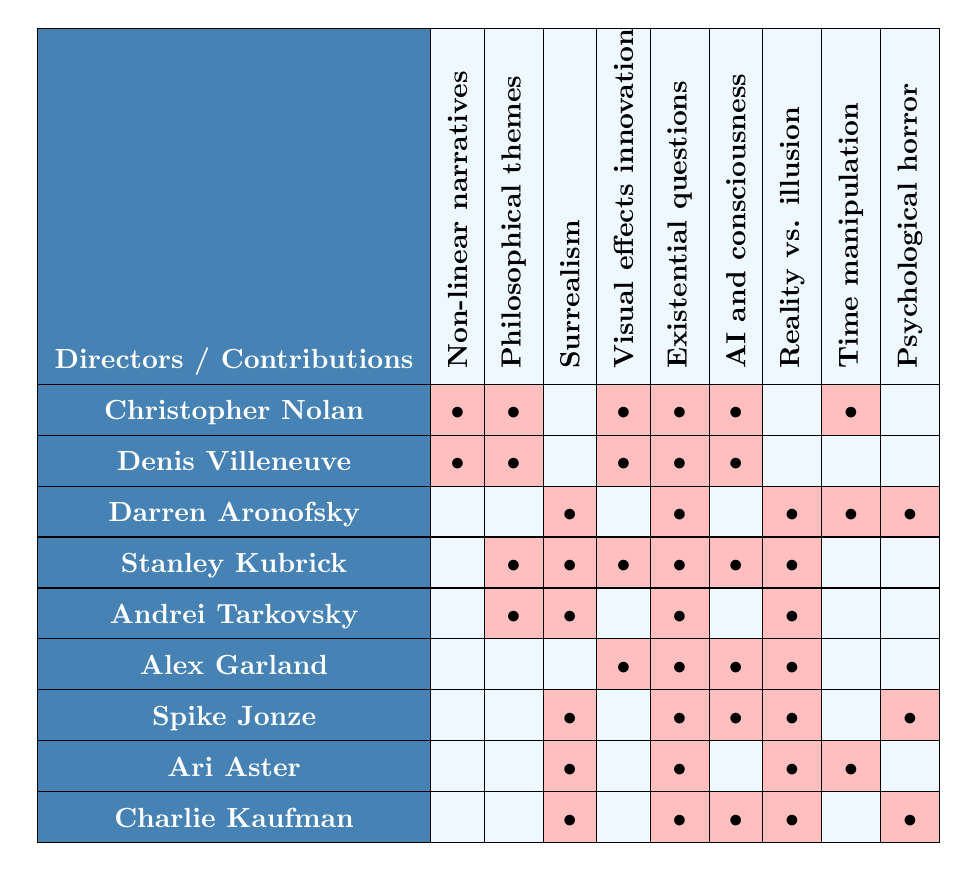What contributions does Christopher Nolan make to mind-bending sci-fi cinema? By referring to Nolan's row in the table, we can see he is associated with Non-linear narratives, Philosophical themes, Visual effects innovation, Existential questions, AI and consciousness exploration, and Time manipulation.
Answer: Non-linear narratives, Philosophical themes, Visual effects innovation, Existential questions, AI and consciousness exploration, Time manipulation How many contributions does Denis Villeneuve have in the table? Denis Villeneuve's row shows that he has contributions in Non-linear narratives, Philosophical themes, Visual effects innovation, Existential questions, and AI and consciousness exploration, totaling 5 contributions.
Answer: 5 Does Alex Garland explore AI and consciousness in his films? In the table, Alex Garland's row has a mark under AI and consciousness exploration confirming that he does explore this theme in his films.
Answer: Yes Which director has the most contributions to mind-bending sci-fi cinema based on the table? By counting the marks in each director's row, Stanley Kubrick has the highest total of 7 contributions, indicating that he is the most prolific in this context.
Answer: Stanley Kubrick How many directors utilize the theme of Reality vs. illusion? Looking down the Reality vs. illusion column, there are 5 directors that have a mark in this category, showing that this theme is utilized by 5 directors.
Answer: 5 Identify a director who utilizes Surrealism but does not explore Philosophical themes. From the table, Darren Aronofsky uses Surrealism but has no marks under Philosophical themes, making him a fitting answer to the question.
Answer: Darren Aronofsky Which contributions are exclusively associated with Charlie Kaufman based on the table? Reviewing the table, Charlie Kaufman has marks under Surrealism, Existential questions, AI and consciousness exploration, and Psychological horror, but none of these contributions are unique to him as they appear under other directors too. Hence he does not have exclusively associated contributions.
Answer: None How does the contribution list of Ari Aster compare with that of Spike Jonze? Examining their rows, Ari Aster has marks for Surrealism, Existential questions, Reality vs. illusion, and Psychological horror; whereas Spike Jonze has marks for Surrealism, Existential questions, Reality vs. illusion, and Psychological horror, indicating they share contributions yet do not differ in any themes present.
Answer: They have identical contributions Are there more directors focused on Time manipulation or AI and consciousness exploration? By checking the relevant columns, Time manipulation has 3 directors while AI and consciousness exploration has 4 directors, suggesting that more directors are focused on AI and consciousness exploration.
Answer: AI and consciousness exploration What unique contribution does Stanley Kubrick have that no other director shares? Looking at Stanley Kubrick's contributions, Historical themes and Visual effects innovation are marked under his row, and cross-referencing with other directors’ contributions shows that he is the only one associated with all these, particularly Visual effects innovation.
Answer: Visual effects innovation 